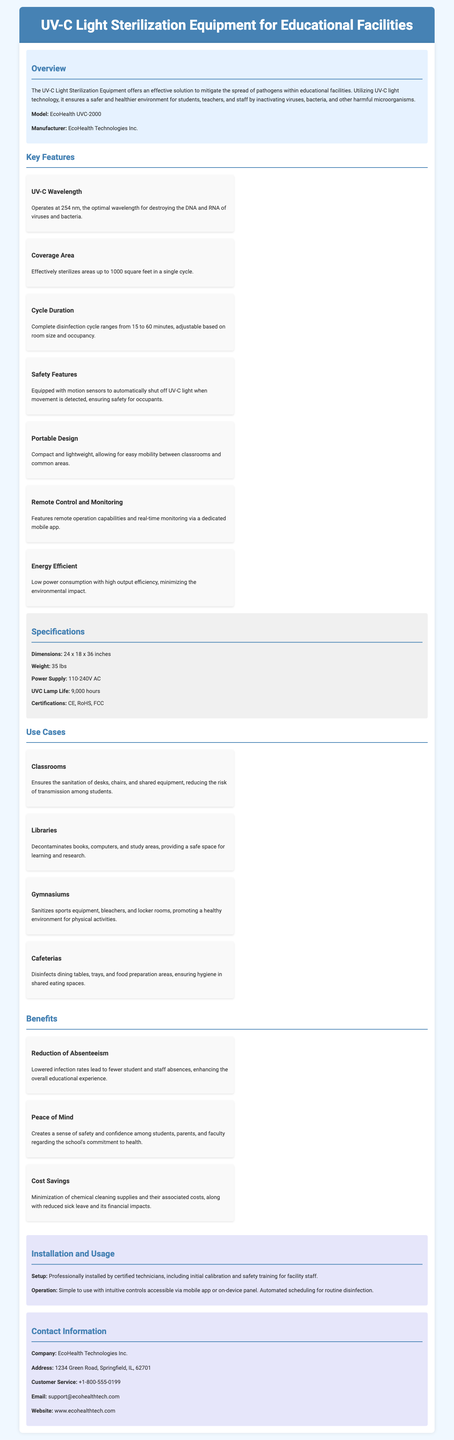What is the model of the equipment? The model of the UV-C light sterilization equipment is mentioned in the overview section of the document.
Answer: EcoHealth UVC-2000 What is the cycle duration range? The cycle duration range is specified under the key features, detailing the time it takes for complete disinfection based on room size and occupancy.
Answer: 15 to 60 minutes What safety feature does the equipment include? The safety feature is highlighted in the key features section, which is crucial for ensuring user safety during operation.
Answer: Motion sensors What is the coverage area of the sterilization equipment? The coverage area is described under the key features section, indicating the effective span of the equipment in a single cycle.
Answer: 1000 square feet How long is the UVC lamp life? The UVC lamp life is listed in the specifications section of the document, providing crucial information about maintenance cycles.
Answer: 9,000 hours What type of spaces can the equipment be used in? The use cases describe specific environments where the UV-C sterilization equipment can be beneficial for sanitation.
Answer: Classrooms, Libraries, Gymnasiums, Cafeterias What is a significant benefit mentioned in the document? The benefits section outlines various advantages of using the UV-C equipment, contributing to a healthier educational environment.
Answer: Reduction of Absenteeism Who is the manufacturer of the equipment? The manufacturer's name is stated in the overview section and is essential for referencing the source of the product.
Answer: EcoHealth Technologies Inc What safety protocols are included during installation? The installation section details the protocols involved in setting up the equipment safely and effectively for user confidence.
Answer: Professional installation by certified technicians 